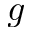<formula> <loc_0><loc_0><loc_500><loc_500>g</formula> 